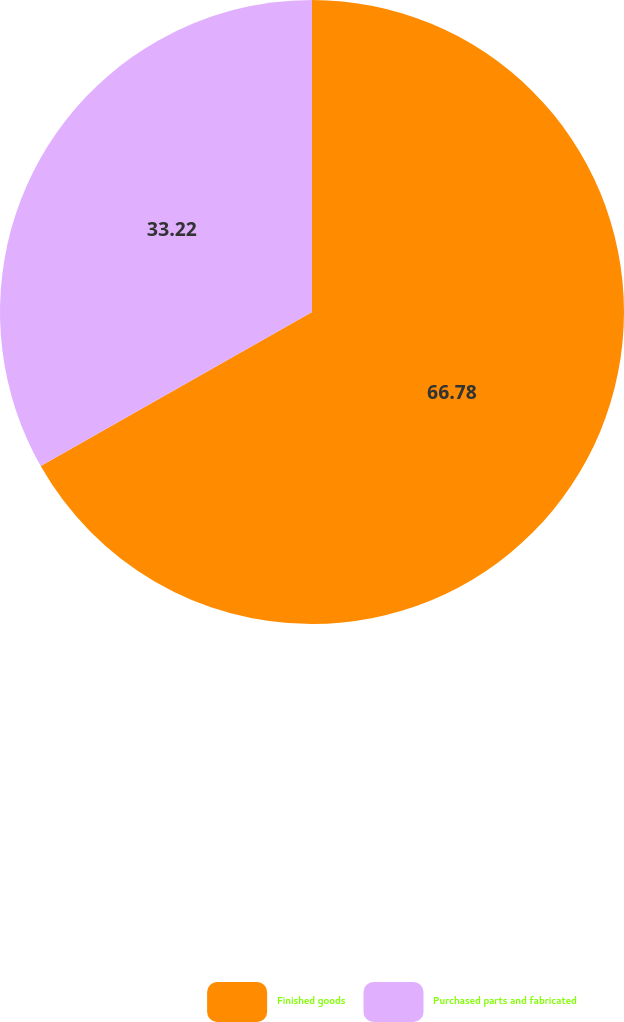<chart> <loc_0><loc_0><loc_500><loc_500><pie_chart><fcel>Finished goods<fcel>Purchased parts and fabricated<nl><fcel>66.78%<fcel>33.22%<nl></chart> 